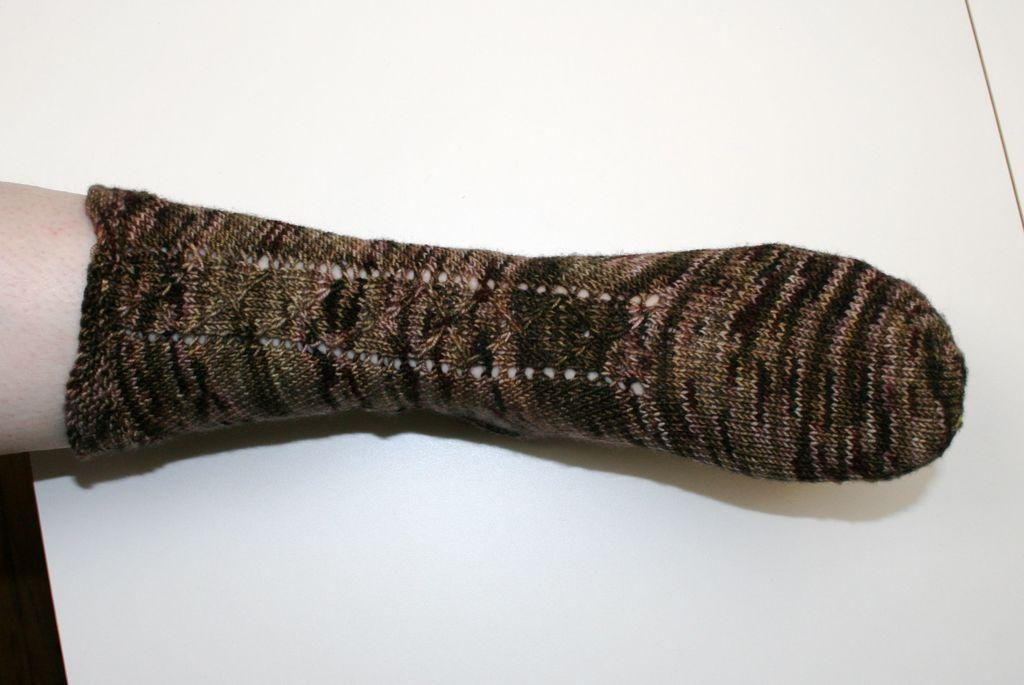What part of a person's body is visible in the image? There is a leg of a person visible in the image. Can you describe the position of the leg in the image? The leg is on the ground. What type of page is being shown in the image? There is no page present in the image; it only features a leg on the ground. 